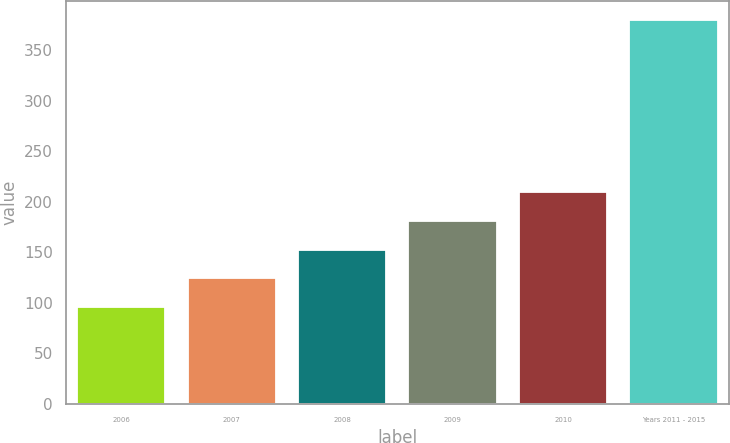<chart> <loc_0><loc_0><loc_500><loc_500><bar_chart><fcel>2006<fcel>2007<fcel>2008<fcel>2009<fcel>2010<fcel>Years 2011 - 2015<nl><fcel>96<fcel>124.4<fcel>152.8<fcel>181.2<fcel>209.6<fcel>380<nl></chart> 